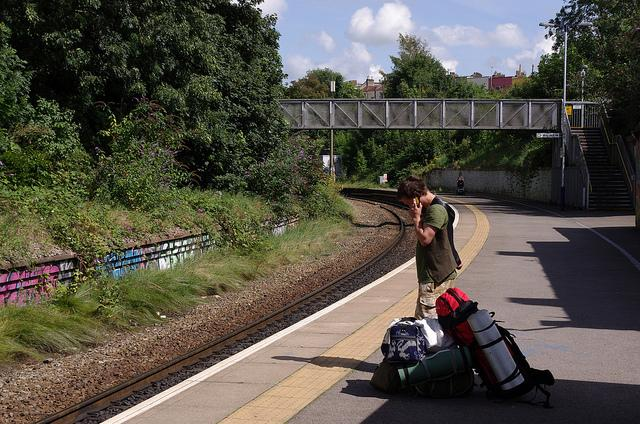If you had to cross to the other side how would you do it?

Choices:
A) overhead bridge
B) swing over
C) cross tracks
D) take taxi overhead bridge 